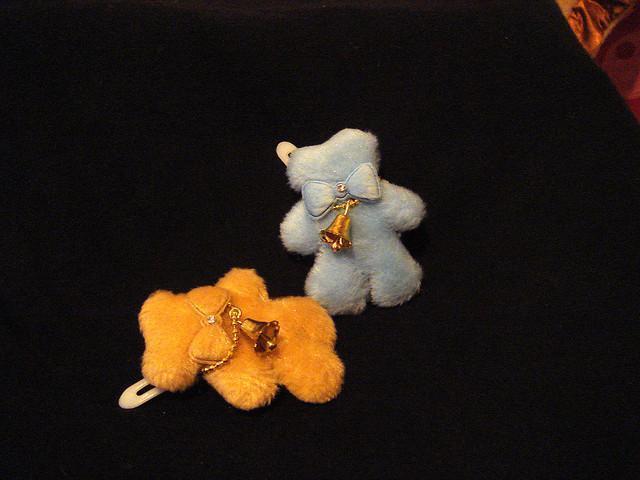How many bells?
Give a very brief answer. 2. How many teddy bears are there?
Give a very brief answer. 2. How many zebra near from tree?
Give a very brief answer. 0. 